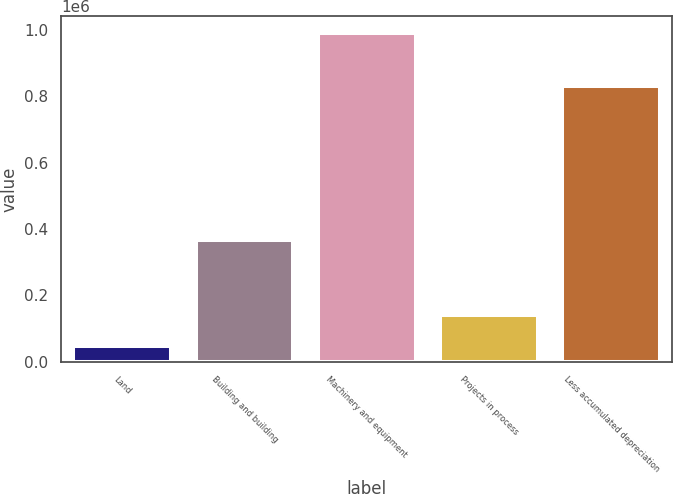<chart> <loc_0><loc_0><loc_500><loc_500><bar_chart><fcel>Land<fcel>Building and building<fcel>Machinery and equipment<fcel>Projects in process<fcel>Less accumulated depreciation<nl><fcel>47212<fcel>366055<fcel>991452<fcel>141636<fcel>832088<nl></chart> 